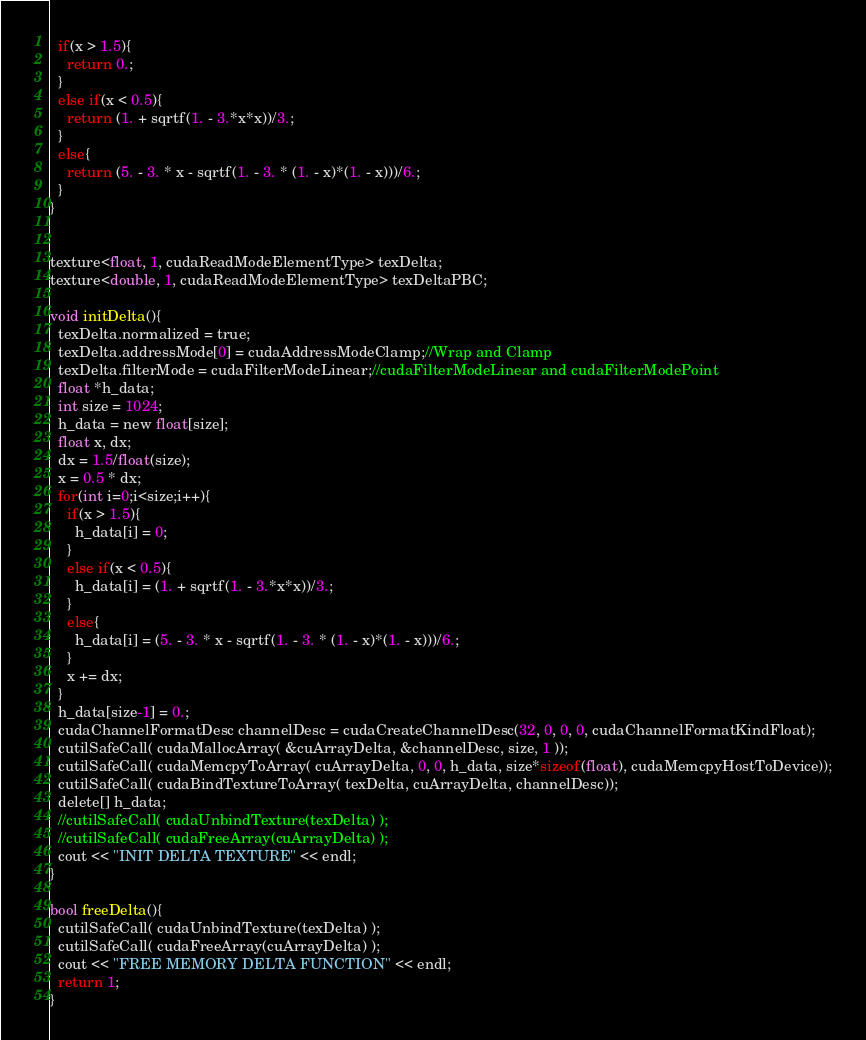<code> <loc_0><loc_0><loc_500><loc_500><_Cuda_>  if(x > 1.5){
    return 0.;
  }
  else if(x < 0.5){
    return (1. + sqrtf(1. - 3.*x*x))/3.;
  }
  else{
    return (5. - 3. * x - sqrtf(1. - 3. * (1. - x)*(1. - x)))/6.;
  }
}


texture<float, 1, cudaReadModeElementType> texDelta; 
texture<double, 1, cudaReadModeElementType> texDeltaPBC; 

void initDelta(){
  texDelta.normalized = true;
  texDelta.addressMode[0] = cudaAddressModeClamp;//Wrap and Clamp
  texDelta.filterMode = cudaFilterModeLinear;//cudaFilterModeLinear and cudaFilterModePoint
  float *h_data;
  int size = 1024;
  h_data = new float[size];
  float x, dx;
  dx = 1.5/float(size);
  x = 0.5 * dx;
  for(int i=0;i<size;i++){
    if(x > 1.5){
      h_data[i] = 0;
    }
    else if(x < 0.5){
      h_data[i] = (1. + sqrtf(1. - 3.*x*x))/3.;
    }
    else{
      h_data[i] = (5. - 3. * x - sqrtf(1. - 3. * (1. - x)*(1. - x)))/6.;
    }
    x += dx;
  }
  h_data[size-1] = 0.;
  cudaChannelFormatDesc channelDesc = cudaCreateChannelDesc(32, 0, 0, 0, cudaChannelFormatKindFloat);
  cutilSafeCall( cudaMallocArray( &cuArrayDelta, &channelDesc, size, 1 )); 
  cutilSafeCall( cudaMemcpyToArray( cuArrayDelta, 0, 0, h_data, size*sizeof(float), cudaMemcpyHostToDevice));
  cutilSafeCall( cudaBindTextureToArray( texDelta, cuArrayDelta, channelDesc));
  delete[] h_data;
  //cutilSafeCall( cudaUnbindTexture(texDelta) );
  //cutilSafeCall( cudaFreeArray(cuArrayDelta) );
  cout << "INIT DELTA TEXTURE" << endl;
}

bool freeDelta(){
  cutilSafeCall( cudaUnbindTexture(texDelta) );
  cutilSafeCall( cudaFreeArray(cuArrayDelta) );
  cout << "FREE MEMORY DELTA FUNCTION" << endl;
  return 1;
}





</code> 